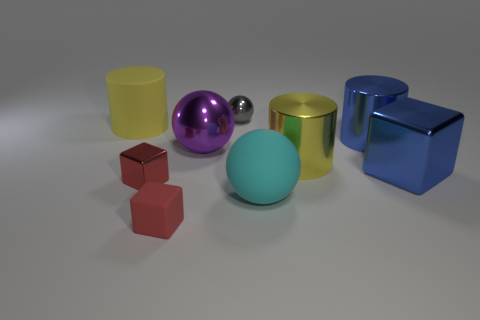How many objects are there in total in the image? There are seven objects in total within the image. 